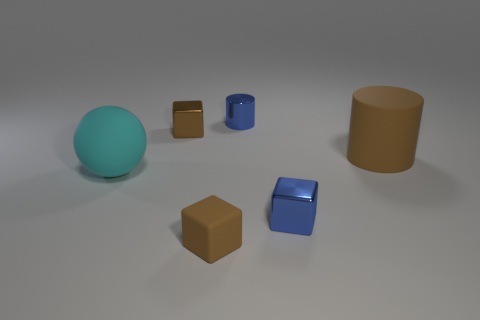There is a matte cylinder; does it have the same color as the tiny metallic block to the left of the metallic cylinder?
Your answer should be compact. Yes. There is a small object that is the same color as the tiny cylinder; what shape is it?
Offer a terse response. Cube. Does the big cylinder have the same color as the small rubber thing?
Provide a short and direct response. Yes. The block that is the same color as the tiny matte object is what size?
Provide a short and direct response. Small. What is the large thing that is on the left side of the small blue cylinder made of?
Provide a succinct answer. Rubber. Is the number of balls right of the matte cylinder the same as the number of green shiny balls?
Your answer should be compact. Yes. There is a brown block in front of the brown rubber thing that is behind the brown matte block; what is its material?
Keep it short and to the point. Rubber. What shape is the thing that is both to the right of the large cyan object and left of the small brown rubber object?
Your answer should be compact. Cube. There is another brown object that is the same shape as the tiny brown rubber object; what is its size?
Ensure brevity in your answer.  Small. Are there fewer brown shiny objects left of the brown shiny block than big green rubber objects?
Ensure brevity in your answer.  No. 